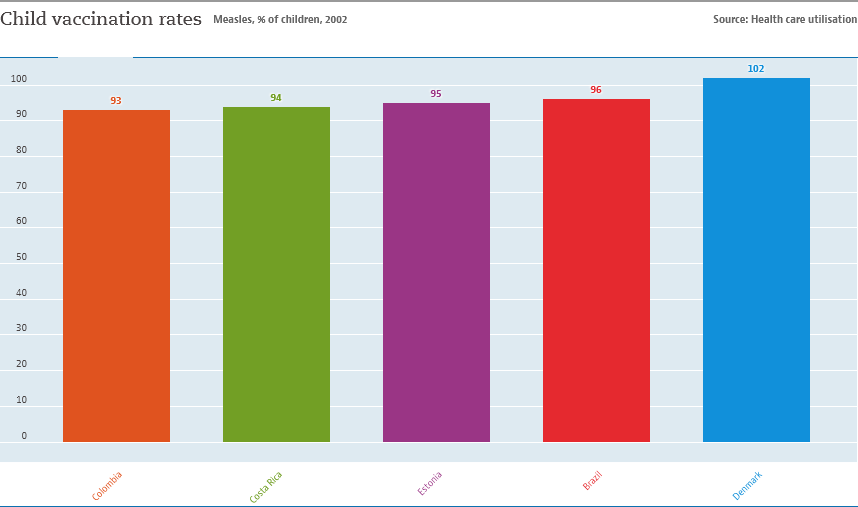Point out several critical features in this image. We will find the differences between each set of data from left to right and add the differences for the following sets: 93-94, 94-95, 95-96, and 96-102. This will reveal the changes in values between each consecutive set of data. The value of the green bar is 94. 